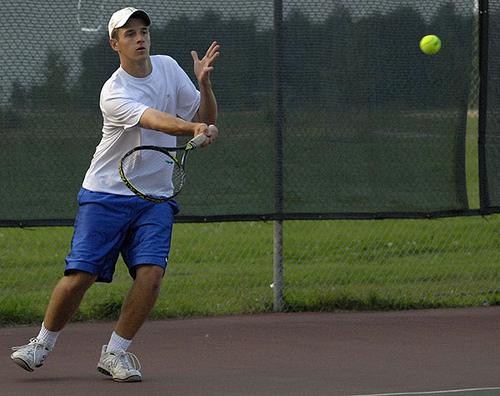What hand is this man holding a racquet?
Be succinct. Right. What color is the racket?
Short answer required. Black. Is he playing soccer?
Be succinct. No. Is the athlete professional?
Be succinct. No. Are the shorts real short?
Answer briefly. No. What is in the man's hand?
Give a very brief answer. Tennis racket. How many persons are wearing hats?
Concise answer only. 1. Is the foremost man wearing his hat properly?
Give a very brief answer. Yes. Is he holding the racket with both hands?
Be succinct. No. What does the man have in his hand?
Quick response, please. Racket. Is he jumping?
Write a very short answer. No. What kind of sport is this?
Quick response, please. Tennis. Who is the leading tennis player of the world?
Be succinct. Agassi. What color is the ball?
Give a very brief answer. Yellow. What sport is being played in this image?
Keep it brief. Tennis. What is man doing?
Concise answer only. Playing tennis. 